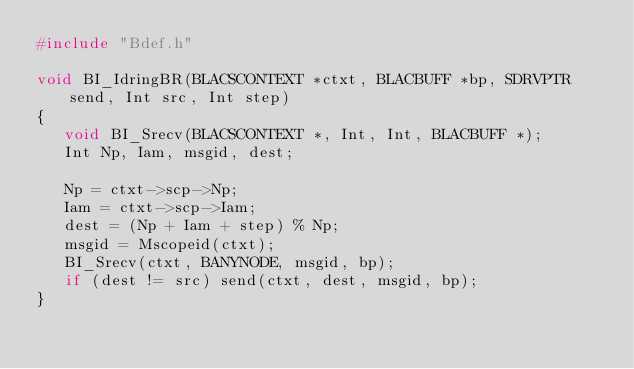<code> <loc_0><loc_0><loc_500><loc_500><_C_>#include "Bdef.h"

void BI_IdringBR(BLACSCONTEXT *ctxt, BLACBUFF *bp, SDRVPTR send, Int src, Int step)
{
   void BI_Srecv(BLACSCONTEXT *, Int, Int, BLACBUFF *);
   Int Np, Iam, msgid, dest;

   Np = ctxt->scp->Np;
   Iam = ctxt->scp->Iam;
   dest = (Np + Iam + step) % Np;
   msgid = Mscopeid(ctxt);
   BI_Srecv(ctxt, BANYNODE, msgid, bp);
   if (dest != src) send(ctxt, dest, msgid, bp);
}
</code> 